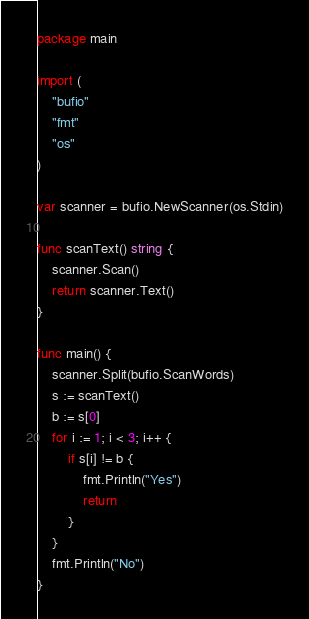<code> <loc_0><loc_0><loc_500><loc_500><_Go_>package main

import (
	"bufio"
	"fmt"
	"os"
)

var scanner = bufio.NewScanner(os.Stdin)

func scanText() string {
	scanner.Scan()
	return scanner.Text()
}

func main() {
	scanner.Split(bufio.ScanWords)
	s := scanText()
	b := s[0]
	for i := 1; i < 3; i++ {
		if s[i] != b {
			fmt.Println("Yes")
			return
		}
	}
	fmt.Println("No")
}</code> 